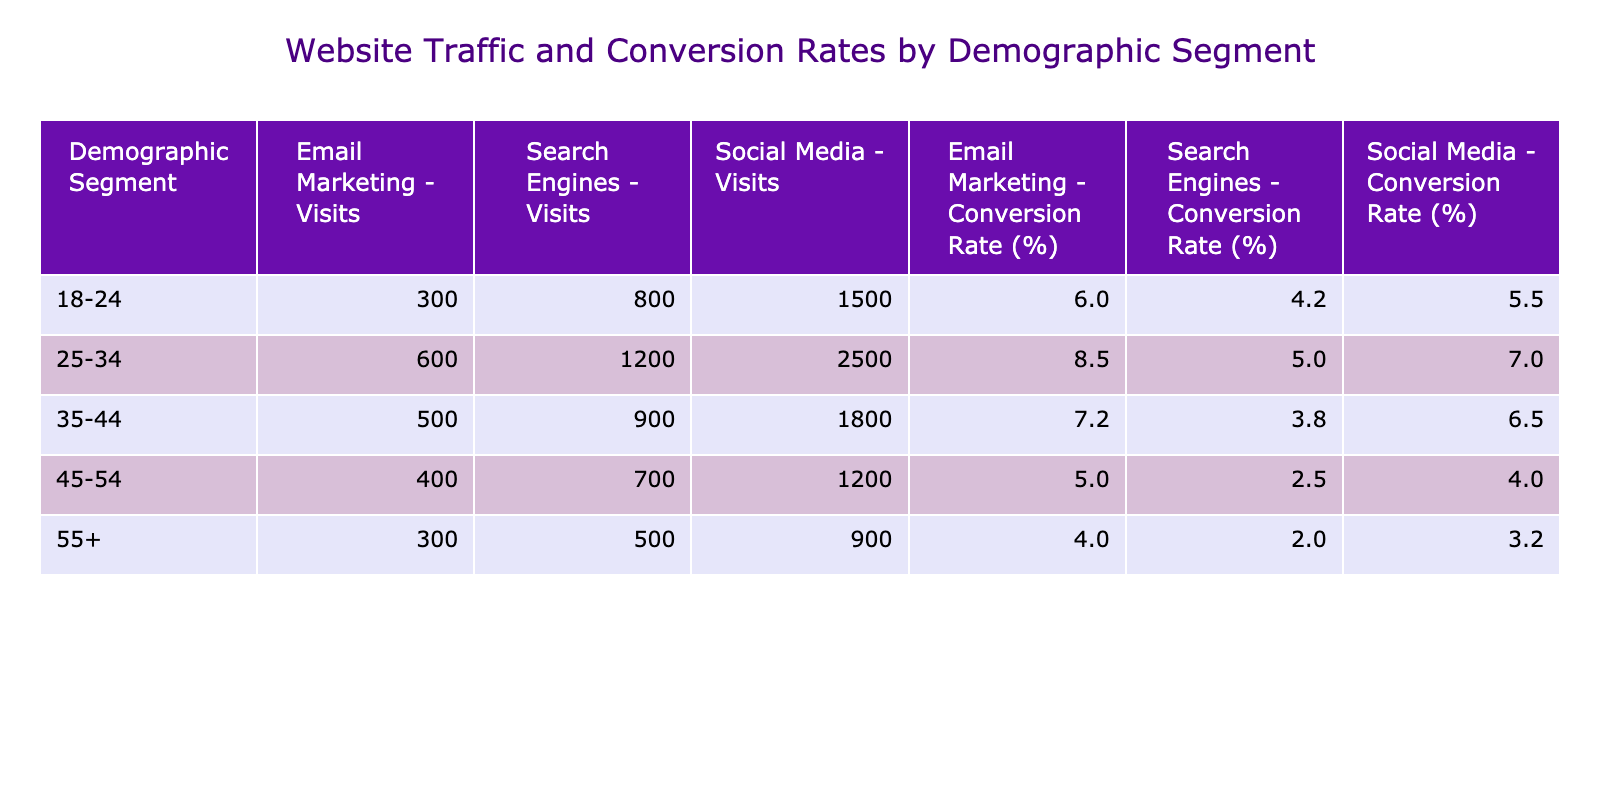What is the conversion rate for the 25-34 age group from Email Marketing? The table shows the conversion rates broken down by demographic segment and website traffic source. For the 25-34 age group, the Email Marketing conversion rate is specified in the table as 8.5%.
Answer: 8.5% Which demographic segment has the highest conversion rate from Social Media? By examining the Social Media conversion rates across the demographic segments, the 25-34 age group shows a conversion rate of 7.0%, which is higher than the rates for the other segments (18-24 at 5.5%, 35-44 at 6.5%, 45-54 at 4.0%, and 55+ at 3.2%). Therefore, the 25-34 age group has the highest conversion rate from Social Media.
Answer: 25-34 What is the total number of visits from Search Engines across all demographic segments? To calculate the total visits from Search Engines, I will sum the visits for each age group: 800 (18-24) + 1200 (25-34) + 900 (35-44) + 700 (45-54) + 500 (55+) = 4100 visits in total from Search Engines.
Answer: 4100 Is the conversion rate for Email Marketing higher than for Search Engines in the 35-44 demographic segment? For the 35-44 demographic segment, the conversion rate for Email Marketing is 7.2%, while the conversion rate for Search Engines is 3.8%. Since 7.2% is greater than 3.8%, the statement is true.
Answer: Yes Which demographic segment has the least number of visits from Email Marketing, and what is that number? By looking at the visits from Email Marketing, the values are: 300 for 18-24, 600 for 25-34, 500 for 35-44, 400 for 45-54, and 300 for 55+. The segments 18-24 and 55+ both have the least visits from Email Marketing at 300.
Answer: 18-24 and 55+ with 300 visits each What is the average conversion rate from Social Media across all demographic segments? The conversion rates from Social Media are: 5.5% (18-24), 7.0% (25-34), 6.5% (35-44), 4.0% (45-54), and 3.2% (55+). To find the average, I will sum these rates (5.5 + 7.0 + 6.5 + 4.0 + 3.2) = 26.2% and then divide by the number of segments (5). Thus, the average is 26.2/5 = 5.24%.
Answer: 5.24% Is there any demographic segment where the conversion rate from Search Engines is above 5%? Checking the conversion rates for Search Engines, we find 4.2% for 18-24, 5.0% for 25-34, 3.8% for 35-44, 2.5% for 45-54, and 2.0% for 55+. The only segment with a conversion rate above 5% is the 25-34 group.
Answer: Yes What is the total visits from all sources for the 45-54 age group? The visits for the 45-54 demographic group are: 1200 from Social Media, 700 from Search Engines, and 400 from Email Marketing. Adding these together gives 1200 + 700 + 400 = 2300 visits in total for the 45-54 age group.
Answer: 2300 